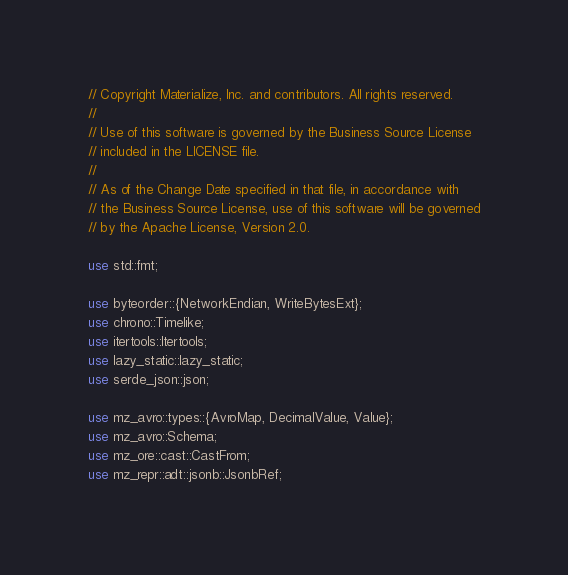Convert code to text. <code><loc_0><loc_0><loc_500><loc_500><_Rust_>// Copyright Materialize, Inc. and contributors. All rights reserved.
//
// Use of this software is governed by the Business Source License
// included in the LICENSE file.
//
// As of the Change Date specified in that file, in accordance with
// the Business Source License, use of this software will be governed
// by the Apache License, Version 2.0.

use std::fmt;

use byteorder::{NetworkEndian, WriteBytesExt};
use chrono::Timelike;
use itertools::Itertools;
use lazy_static::lazy_static;
use serde_json::json;

use mz_avro::types::{AvroMap, DecimalValue, Value};
use mz_avro::Schema;
use mz_ore::cast::CastFrom;
use mz_repr::adt::jsonb::JsonbRef;</code> 